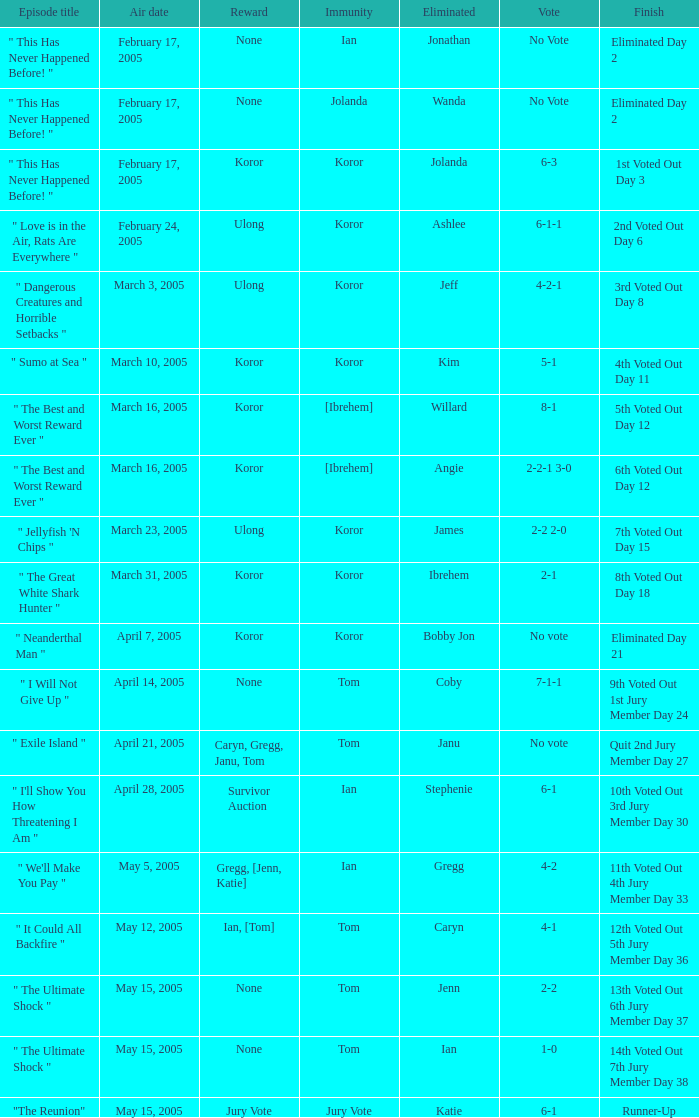For the "6th voted out day 12" conclusion, how many votes were involved? 1.0. 